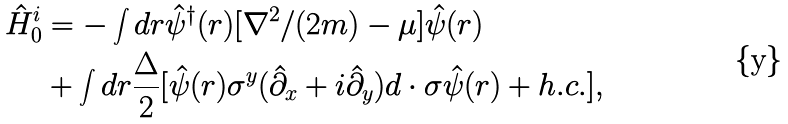Convert formula to latex. <formula><loc_0><loc_0><loc_500><loc_500>\hat { H } ^ { i } _ { 0 } & = - \int d r \hat { \psi } ^ { \dagger } ( r ) [ \nabla ^ { 2 } / ( 2 { m } ) - \mu ] \hat { \psi } ( r ) \\ & + \int d r \frac { \Delta } { 2 } [ \hat { \psi } ( r ) \sigma ^ { y } ( \hat { \partial } _ { x } + i \hat { \partial } _ { y } ) d \cdot { \sigma } \hat { \psi } ( r ) + h . c . ] ,</formula> 